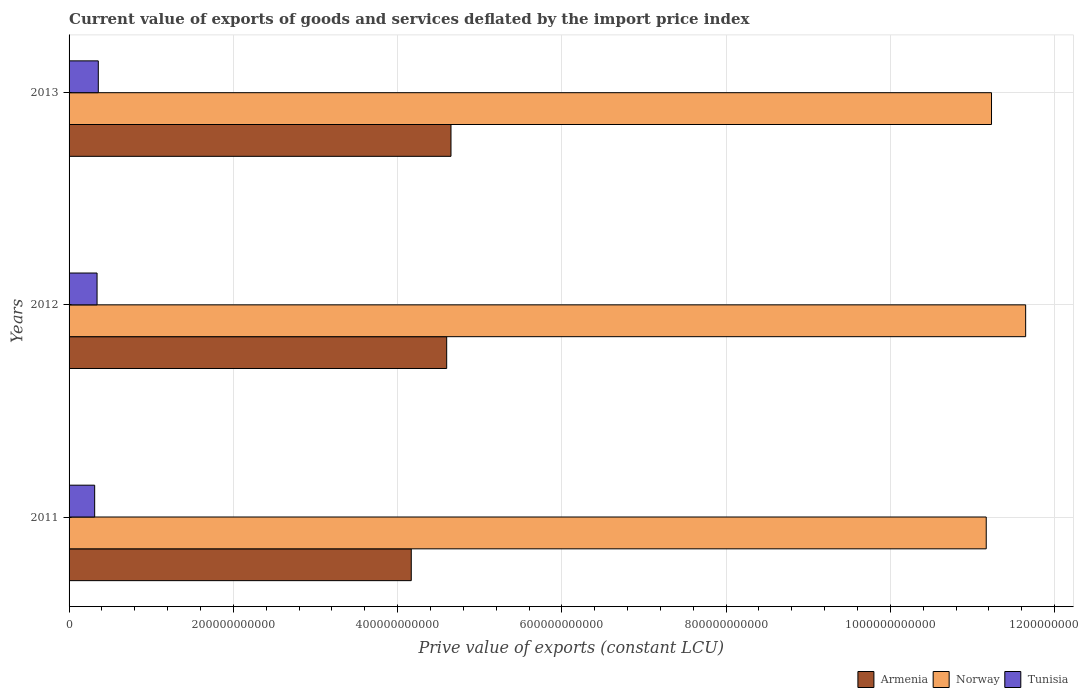How many different coloured bars are there?
Your answer should be very brief. 3. Are the number of bars per tick equal to the number of legend labels?
Give a very brief answer. Yes. Are the number of bars on each tick of the Y-axis equal?
Provide a short and direct response. Yes. How many bars are there on the 1st tick from the bottom?
Ensure brevity in your answer.  3. In how many cases, is the number of bars for a given year not equal to the number of legend labels?
Your answer should be compact. 0. What is the prive value of exports in Armenia in 2012?
Your response must be concise. 4.60e+11. Across all years, what is the maximum prive value of exports in Armenia?
Make the answer very short. 4.65e+11. Across all years, what is the minimum prive value of exports in Tunisia?
Your response must be concise. 3.12e+1. In which year was the prive value of exports in Armenia minimum?
Keep it short and to the point. 2011. What is the total prive value of exports in Armenia in the graph?
Your response must be concise. 1.34e+12. What is the difference between the prive value of exports in Norway in 2011 and that in 2013?
Make the answer very short. -6.43e+09. What is the difference between the prive value of exports in Tunisia in 2011 and the prive value of exports in Armenia in 2012?
Your answer should be very brief. -4.29e+11. What is the average prive value of exports in Tunisia per year?
Provide a short and direct response. 3.36e+1. In the year 2013, what is the difference between the prive value of exports in Armenia and prive value of exports in Norway?
Make the answer very short. -6.58e+11. In how many years, is the prive value of exports in Armenia greater than 200000000000 LCU?
Your answer should be very brief. 3. What is the ratio of the prive value of exports in Armenia in 2011 to that in 2013?
Provide a short and direct response. 0.9. Is the prive value of exports in Tunisia in 2012 less than that in 2013?
Offer a terse response. Yes. What is the difference between the highest and the second highest prive value of exports in Tunisia?
Your answer should be very brief. 1.51e+09. What is the difference between the highest and the lowest prive value of exports in Tunisia?
Offer a very short reply. 4.41e+09. In how many years, is the prive value of exports in Norway greater than the average prive value of exports in Norway taken over all years?
Offer a very short reply. 1. Is the sum of the prive value of exports in Tunisia in 2011 and 2012 greater than the maximum prive value of exports in Norway across all years?
Keep it short and to the point. No. What does the 2nd bar from the top in 2011 represents?
Give a very brief answer. Norway. What does the 1st bar from the bottom in 2013 represents?
Provide a succinct answer. Armenia. Is it the case that in every year, the sum of the prive value of exports in Tunisia and prive value of exports in Norway is greater than the prive value of exports in Armenia?
Ensure brevity in your answer.  Yes. How many bars are there?
Provide a short and direct response. 9. Are all the bars in the graph horizontal?
Ensure brevity in your answer.  Yes. How many years are there in the graph?
Provide a succinct answer. 3. What is the difference between two consecutive major ticks on the X-axis?
Offer a terse response. 2.00e+11. Does the graph contain grids?
Give a very brief answer. Yes. How many legend labels are there?
Offer a terse response. 3. How are the legend labels stacked?
Your response must be concise. Horizontal. What is the title of the graph?
Your answer should be compact. Current value of exports of goods and services deflated by the import price index. Does "Macao" appear as one of the legend labels in the graph?
Provide a short and direct response. No. What is the label or title of the X-axis?
Your response must be concise. Prive value of exports (constant LCU). What is the label or title of the Y-axis?
Give a very brief answer. Years. What is the Prive value of exports (constant LCU) in Armenia in 2011?
Ensure brevity in your answer.  4.17e+11. What is the Prive value of exports (constant LCU) of Norway in 2011?
Keep it short and to the point. 1.12e+12. What is the Prive value of exports (constant LCU) of Tunisia in 2011?
Provide a short and direct response. 3.12e+1. What is the Prive value of exports (constant LCU) in Armenia in 2012?
Provide a short and direct response. 4.60e+11. What is the Prive value of exports (constant LCU) of Norway in 2012?
Offer a very short reply. 1.16e+12. What is the Prive value of exports (constant LCU) in Tunisia in 2012?
Offer a terse response. 3.41e+1. What is the Prive value of exports (constant LCU) of Armenia in 2013?
Your answer should be compact. 4.65e+11. What is the Prive value of exports (constant LCU) in Norway in 2013?
Your answer should be very brief. 1.12e+12. What is the Prive value of exports (constant LCU) of Tunisia in 2013?
Offer a terse response. 3.56e+1. Across all years, what is the maximum Prive value of exports (constant LCU) of Armenia?
Offer a terse response. 4.65e+11. Across all years, what is the maximum Prive value of exports (constant LCU) in Norway?
Ensure brevity in your answer.  1.16e+12. Across all years, what is the maximum Prive value of exports (constant LCU) of Tunisia?
Your answer should be very brief. 3.56e+1. Across all years, what is the minimum Prive value of exports (constant LCU) in Armenia?
Provide a short and direct response. 4.17e+11. Across all years, what is the minimum Prive value of exports (constant LCU) in Norway?
Provide a succinct answer. 1.12e+12. Across all years, what is the minimum Prive value of exports (constant LCU) in Tunisia?
Provide a short and direct response. 3.12e+1. What is the total Prive value of exports (constant LCU) of Armenia in the graph?
Your answer should be very brief. 1.34e+12. What is the total Prive value of exports (constant LCU) in Norway in the graph?
Make the answer very short. 3.40e+12. What is the total Prive value of exports (constant LCU) in Tunisia in the graph?
Ensure brevity in your answer.  1.01e+11. What is the difference between the Prive value of exports (constant LCU) of Armenia in 2011 and that in 2012?
Provide a short and direct response. -4.31e+1. What is the difference between the Prive value of exports (constant LCU) in Norway in 2011 and that in 2012?
Provide a succinct answer. -4.80e+1. What is the difference between the Prive value of exports (constant LCU) of Tunisia in 2011 and that in 2012?
Offer a very short reply. -2.90e+09. What is the difference between the Prive value of exports (constant LCU) in Armenia in 2011 and that in 2013?
Ensure brevity in your answer.  -4.84e+1. What is the difference between the Prive value of exports (constant LCU) of Norway in 2011 and that in 2013?
Your response must be concise. -6.43e+09. What is the difference between the Prive value of exports (constant LCU) in Tunisia in 2011 and that in 2013?
Offer a very short reply. -4.41e+09. What is the difference between the Prive value of exports (constant LCU) of Armenia in 2012 and that in 2013?
Ensure brevity in your answer.  -5.23e+09. What is the difference between the Prive value of exports (constant LCU) of Norway in 2012 and that in 2013?
Make the answer very short. 4.16e+1. What is the difference between the Prive value of exports (constant LCU) in Tunisia in 2012 and that in 2013?
Provide a short and direct response. -1.51e+09. What is the difference between the Prive value of exports (constant LCU) of Armenia in 2011 and the Prive value of exports (constant LCU) of Norway in 2012?
Offer a very short reply. -7.48e+11. What is the difference between the Prive value of exports (constant LCU) in Armenia in 2011 and the Prive value of exports (constant LCU) in Tunisia in 2012?
Give a very brief answer. 3.83e+11. What is the difference between the Prive value of exports (constant LCU) of Norway in 2011 and the Prive value of exports (constant LCU) of Tunisia in 2012?
Your response must be concise. 1.08e+12. What is the difference between the Prive value of exports (constant LCU) of Armenia in 2011 and the Prive value of exports (constant LCU) of Norway in 2013?
Offer a very short reply. -7.07e+11. What is the difference between the Prive value of exports (constant LCU) of Armenia in 2011 and the Prive value of exports (constant LCU) of Tunisia in 2013?
Ensure brevity in your answer.  3.81e+11. What is the difference between the Prive value of exports (constant LCU) in Norway in 2011 and the Prive value of exports (constant LCU) in Tunisia in 2013?
Provide a short and direct response. 1.08e+12. What is the difference between the Prive value of exports (constant LCU) in Armenia in 2012 and the Prive value of exports (constant LCU) in Norway in 2013?
Offer a very short reply. -6.63e+11. What is the difference between the Prive value of exports (constant LCU) of Armenia in 2012 and the Prive value of exports (constant LCU) of Tunisia in 2013?
Offer a terse response. 4.24e+11. What is the difference between the Prive value of exports (constant LCU) in Norway in 2012 and the Prive value of exports (constant LCU) in Tunisia in 2013?
Provide a short and direct response. 1.13e+12. What is the average Prive value of exports (constant LCU) of Armenia per year?
Provide a succinct answer. 4.47e+11. What is the average Prive value of exports (constant LCU) of Norway per year?
Your response must be concise. 1.13e+12. What is the average Prive value of exports (constant LCU) in Tunisia per year?
Provide a succinct answer. 3.36e+1. In the year 2011, what is the difference between the Prive value of exports (constant LCU) of Armenia and Prive value of exports (constant LCU) of Norway?
Make the answer very short. -7.00e+11. In the year 2011, what is the difference between the Prive value of exports (constant LCU) of Armenia and Prive value of exports (constant LCU) of Tunisia?
Your answer should be very brief. 3.85e+11. In the year 2011, what is the difference between the Prive value of exports (constant LCU) in Norway and Prive value of exports (constant LCU) in Tunisia?
Make the answer very short. 1.09e+12. In the year 2012, what is the difference between the Prive value of exports (constant LCU) of Armenia and Prive value of exports (constant LCU) of Norway?
Provide a short and direct response. -7.05e+11. In the year 2012, what is the difference between the Prive value of exports (constant LCU) of Armenia and Prive value of exports (constant LCU) of Tunisia?
Your answer should be very brief. 4.26e+11. In the year 2012, what is the difference between the Prive value of exports (constant LCU) in Norway and Prive value of exports (constant LCU) in Tunisia?
Provide a succinct answer. 1.13e+12. In the year 2013, what is the difference between the Prive value of exports (constant LCU) in Armenia and Prive value of exports (constant LCU) in Norway?
Give a very brief answer. -6.58e+11. In the year 2013, what is the difference between the Prive value of exports (constant LCU) in Armenia and Prive value of exports (constant LCU) in Tunisia?
Give a very brief answer. 4.29e+11. In the year 2013, what is the difference between the Prive value of exports (constant LCU) in Norway and Prive value of exports (constant LCU) in Tunisia?
Your answer should be very brief. 1.09e+12. What is the ratio of the Prive value of exports (constant LCU) in Armenia in 2011 to that in 2012?
Keep it short and to the point. 0.91. What is the ratio of the Prive value of exports (constant LCU) of Norway in 2011 to that in 2012?
Your answer should be compact. 0.96. What is the ratio of the Prive value of exports (constant LCU) in Tunisia in 2011 to that in 2012?
Ensure brevity in your answer.  0.92. What is the ratio of the Prive value of exports (constant LCU) of Armenia in 2011 to that in 2013?
Offer a terse response. 0.9. What is the ratio of the Prive value of exports (constant LCU) of Tunisia in 2011 to that in 2013?
Keep it short and to the point. 0.88. What is the ratio of the Prive value of exports (constant LCU) of Armenia in 2012 to that in 2013?
Offer a very short reply. 0.99. What is the ratio of the Prive value of exports (constant LCU) in Norway in 2012 to that in 2013?
Your response must be concise. 1.04. What is the ratio of the Prive value of exports (constant LCU) in Tunisia in 2012 to that in 2013?
Provide a short and direct response. 0.96. What is the difference between the highest and the second highest Prive value of exports (constant LCU) in Armenia?
Provide a succinct answer. 5.23e+09. What is the difference between the highest and the second highest Prive value of exports (constant LCU) in Norway?
Give a very brief answer. 4.16e+1. What is the difference between the highest and the second highest Prive value of exports (constant LCU) in Tunisia?
Offer a very short reply. 1.51e+09. What is the difference between the highest and the lowest Prive value of exports (constant LCU) in Armenia?
Provide a short and direct response. 4.84e+1. What is the difference between the highest and the lowest Prive value of exports (constant LCU) in Norway?
Provide a succinct answer. 4.80e+1. What is the difference between the highest and the lowest Prive value of exports (constant LCU) of Tunisia?
Provide a succinct answer. 4.41e+09. 